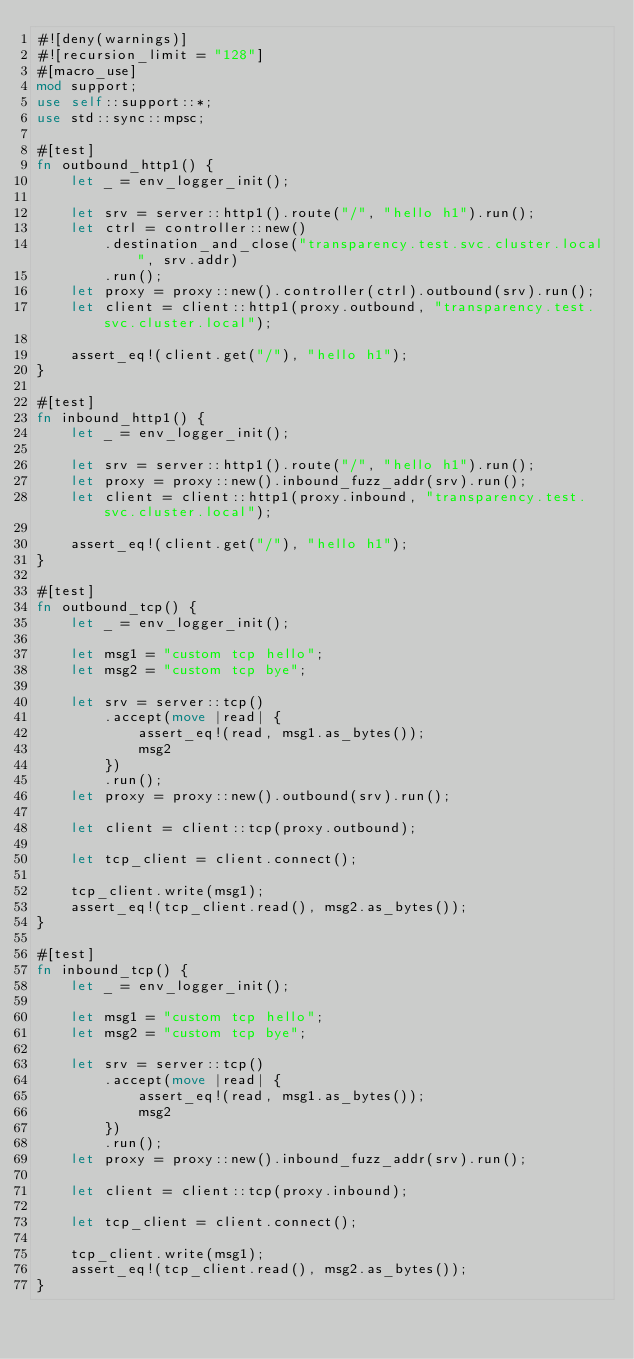<code> <loc_0><loc_0><loc_500><loc_500><_Rust_>#![deny(warnings)]
#![recursion_limit = "128"]
#[macro_use]
mod support;
use self::support::*;
use std::sync::mpsc;

#[test]
fn outbound_http1() {
    let _ = env_logger_init();

    let srv = server::http1().route("/", "hello h1").run();
    let ctrl = controller::new()
        .destination_and_close("transparency.test.svc.cluster.local", srv.addr)
        .run();
    let proxy = proxy::new().controller(ctrl).outbound(srv).run();
    let client = client::http1(proxy.outbound, "transparency.test.svc.cluster.local");

    assert_eq!(client.get("/"), "hello h1");
}

#[test]
fn inbound_http1() {
    let _ = env_logger_init();

    let srv = server::http1().route("/", "hello h1").run();
    let proxy = proxy::new().inbound_fuzz_addr(srv).run();
    let client = client::http1(proxy.inbound, "transparency.test.svc.cluster.local");

    assert_eq!(client.get("/"), "hello h1");
}

#[test]
fn outbound_tcp() {
    let _ = env_logger_init();

    let msg1 = "custom tcp hello";
    let msg2 = "custom tcp bye";

    let srv = server::tcp()
        .accept(move |read| {
            assert_eq!(read, msg1.as_bytes());
            msg2
        })
        .run();
    let proxy = proxy::new().outbound(srv).run();

    let client = client::tcp(proxy.outbound);

    let tcp_client = client.connect();

    tcp_client.write(msg1);
    assert_eq!(tcp_client.read(), msg2.as_bytes());
}

#[test]
fn inbound_tcp() {
    let _ = env_logger_init();

    let msg1 = "custom tcp hello";
    let msg2 = "custom tcp bye";

    let srv = server::tcp()
        .accept(move |read| {
            assert_eq!(read, msg1.as_bytes());
            msg2
        })
        .run();
    let proxy = proxy::new().inbound_fuzz_addr(srv).run();

    let client = client::tcp(proxy.inbound);

    let tcp_client = client.connect();

    tcp_client.write(msg1);
    assert_eq!(tcp_client.read(), msg2.as_bytes());
}
</code> 